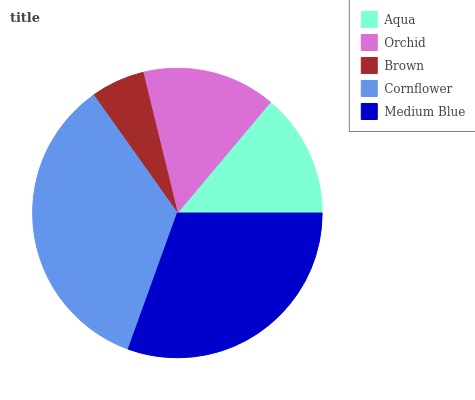Is Brown the minimum?
Answer yes or no. Yes. Is Cornflower the maximum?
Answer yes or no. Yes. Is Orchid the minimum?
Answer yes or no. No. Is Orchid the maximum?
Answer yes or no. No. Is Orchid greater than Aqua?
Answer yes or no. Yes. Is Aqua less than Orchid?
Answer yes or no. Yes. Is Aqua greater than Orchid?
Answer yes or no. No. Is Orchid less than Aqua?
Answer yes or no. No. Is Orchid the high median?
Answer yes or no. Yes. Is Orchid the low median?
Answer yes or no. Yes. Is Aqua the high median?
Answer yes or no. No. Is Brown the low median?
Answer yes or no. No. 